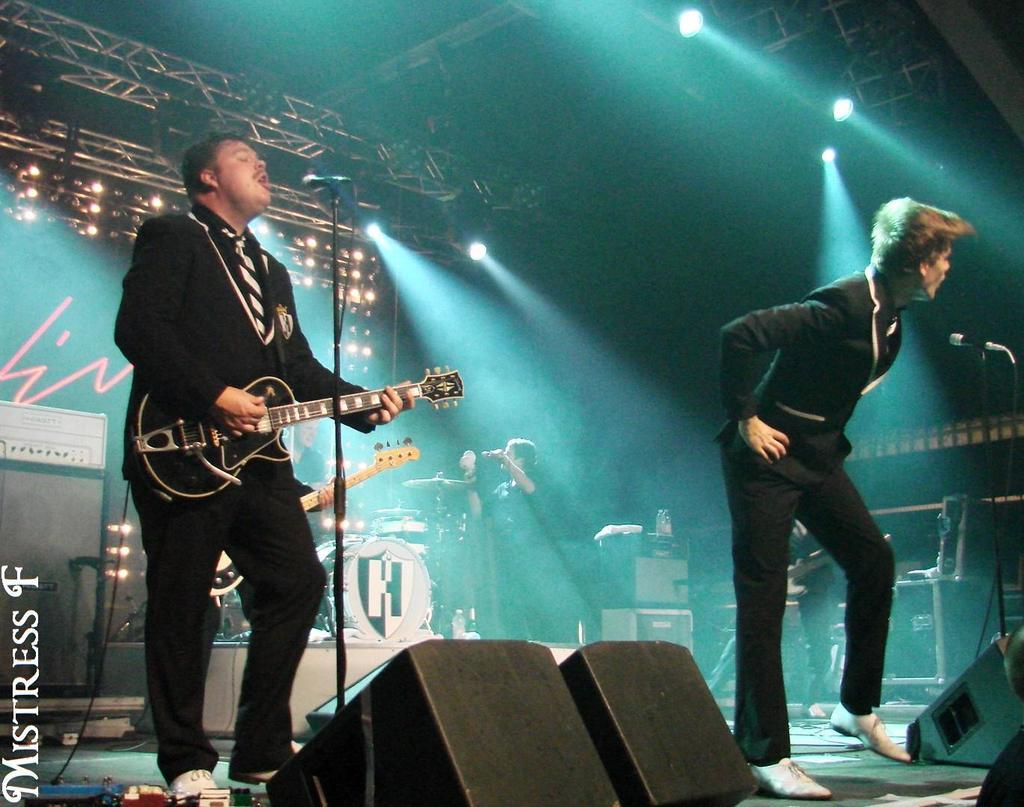How many people are in the image? There are two men in the image. What is one of the men doing in the image? One man is playing a guitar. Where is the man playing the guitar located in relation to the microphone? The man playing the guitar is in front of a microphone. What is the other man doing in the image? The other man is standing on a stage. What type of oven can be seen in the image? There is no oven present in the image. What tool is the man using to work on the guitar? The man is not using any tools to work on the guitar in the image; he is simply playing it. 